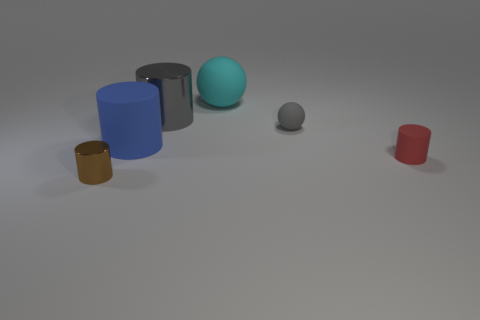Is the number of small shiny cylinders that are to the right of the brown metallic cylinder greater than the number of blue cylinders left of the blue rubber cylinder?
Keep it short and to the point. No. There is a big cyan rubber sphere; are there any large matte things in front of it?
Keep it short and to the point. Yes. Is there a metal cylinder of the same size as the blue matte cylinder?
Keep it short and to the point. Yes. There is another sphere that is the same material as the small gray ball; what is its color?
Keep it short and to the point. Cyan. What is the material of the tiny red cylinder?
Ensure brevity in your answer.  Rubber. There is a small gray rubber object; what shape is it?
Give a very brief answer. Sphere. How many big metal objects have the same color as the large ball?
Your response must be concise. 0. What material is the tiny cylinder on the right side of the matte ball that is behind the matte ball that is right of the big cyan matte ball?
Make the answer very short. Rubber. How many brown objects are big shiny cylinders or metallic cylinders?
Provide a short and direct response. 1. What size is the cyan matte ball that is to the left of the tiny object that is behind the large matte thing in front of the small gray ball?
Your response must be concise. Large. 